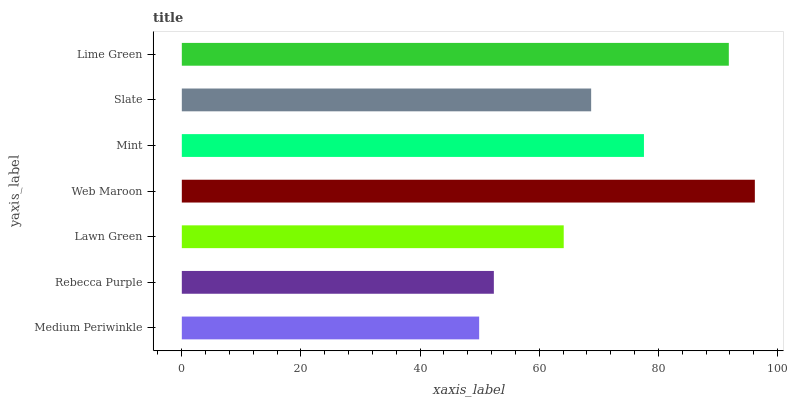Is Medium Periwinkle the minimum?
Answer yes or no. Yes. Is Web Maroon the maximum?
Answer yes or no. Yes. Is Rebecca Purple the minimum?
Answer yes or no. No. Is Rebecca Purple the maximum?
Answer yes or no. No. Is Rebecca Purple greater than Medium Periwinkle?
Answer yes or no. Yes. Is Medium Periwinkle less than Rebecca Purple?
Answer yes or no. Yes. Is Medium Periwinkle greater than Rebecca Purple?
Answer yes or no. No. Is Rebecca Purple less than Medium Periwinkle?
Answer yes or no. No. Is Slate the high median?
Answer yes or no. Yes. Is Slate the low median?
Answer yes or no. Yes. Is Rebecca Purple the high median?
Answer yes or no. No. Is Lime Green the low median?
Answer yes or no. No. 